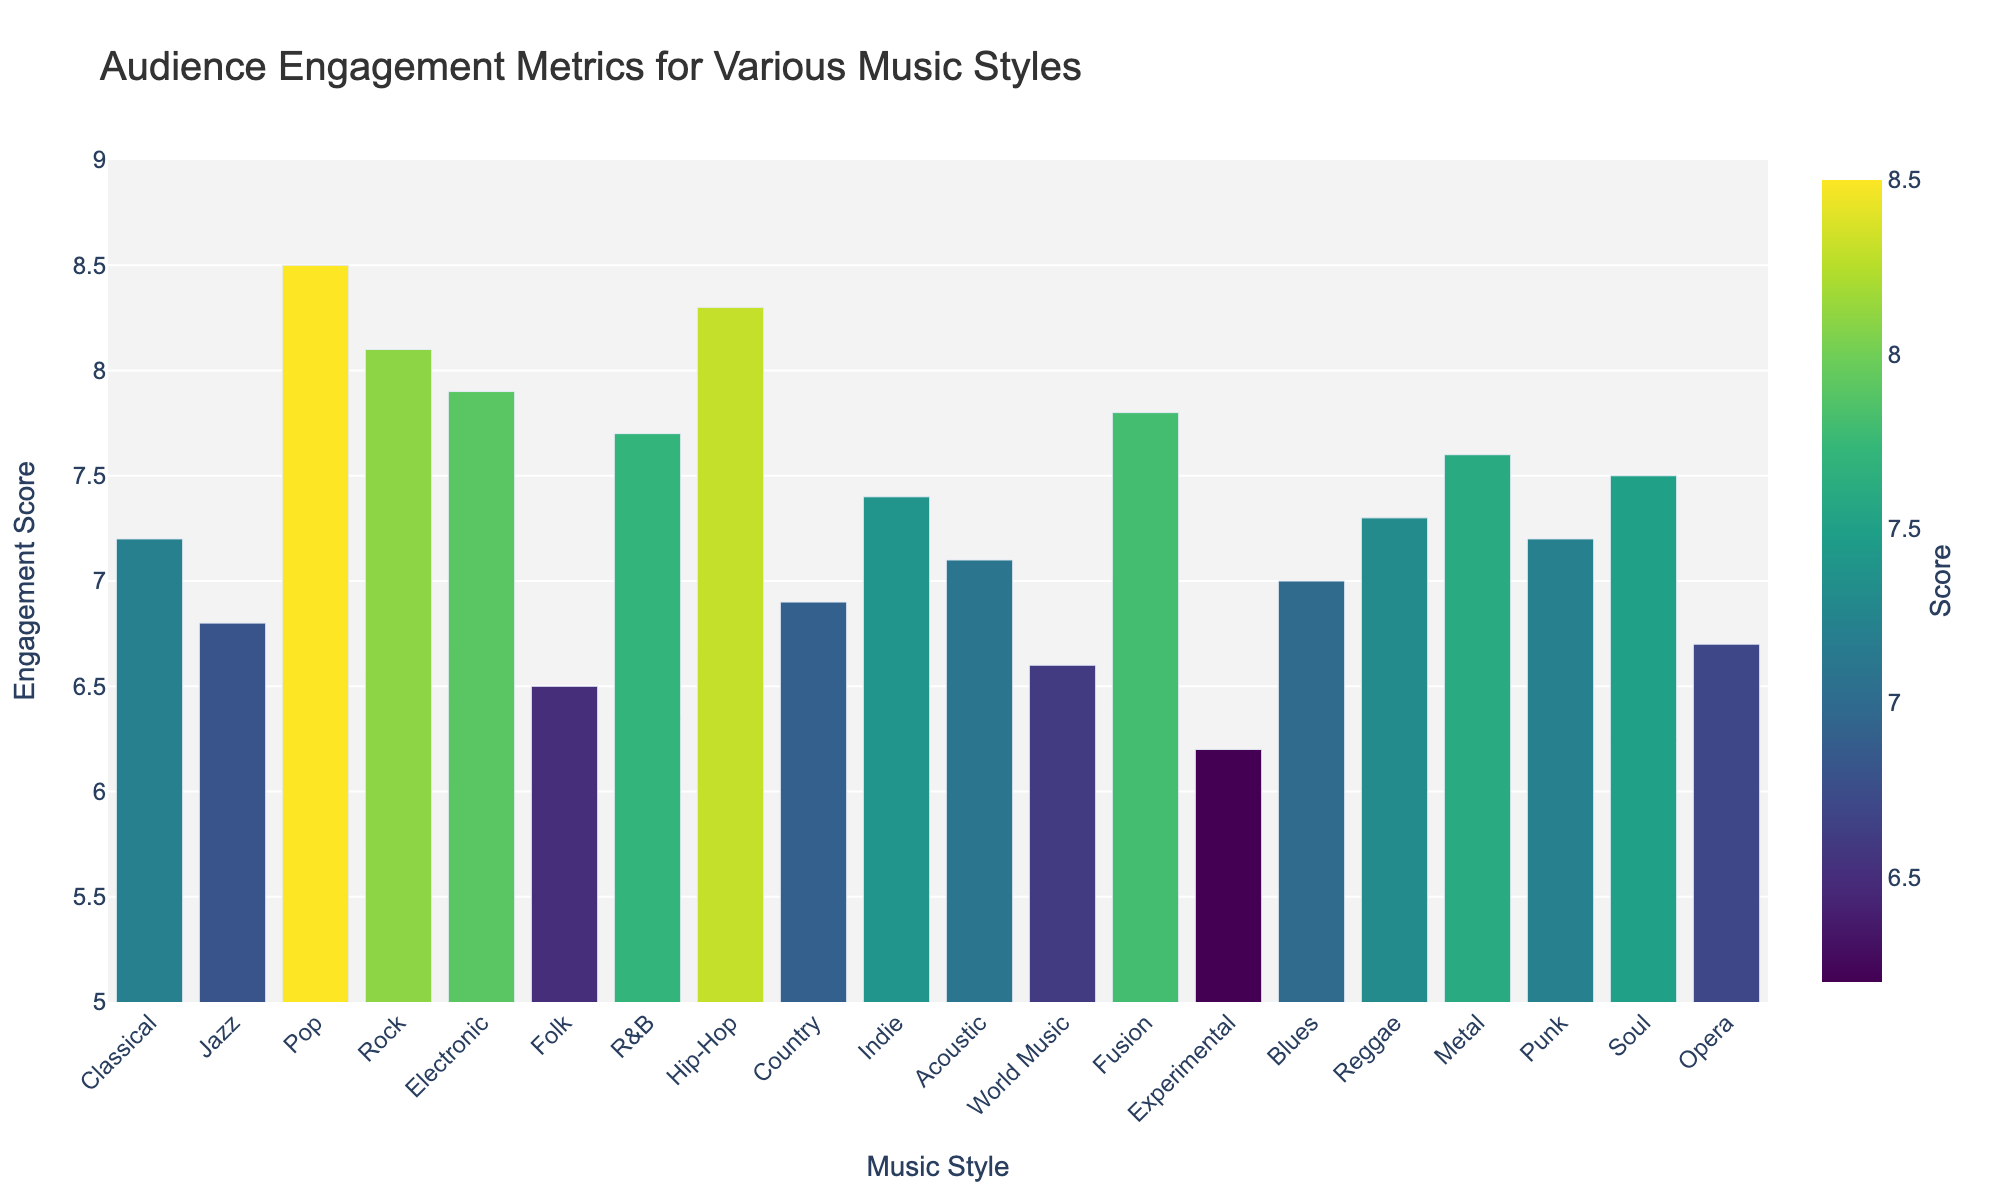Which music style has the highest audience engagement score? The bar representing Pop music has the greatest height, indicating the highest engagement score.
Answer: Pop Which music style has the lowest audience engagement score? The bar representing Experimental music is the shortest, indicating the lowest engagement score.
Answer: Experimental How much higher is the audience engagement score for Rock compared to Classical? The engagement score for Rock is 8.1 and for Classical is 7.2. Subtracting the latter from the former gives 8.1 - 7.2 = 0.9.
Answer: 0.9 Which styles have engagement scores greater than 8? Styles with bars extending beyond the 8 mark on the y-axis include Pop, Rock, and Hip-Hop.
Answer: Pop, Rock, Hip-Hop What is the average engagement score for Classical, Jazz, and Blues? The engagement scores are 7.2 (Classical), 6.8 (Jazz), and 7.0 (Blues). Summing these gives 7.2 + 6.8 + 7.0 = 21.0. Dividing by the number of styles (3) results in 21.0 / 3 = 7.0.
Answer: 7.0 Which genre has a lighter color bar: Reggae or Indie? On the color scale, Reggae has a score of 7.3 and Indie has a score of 7.4. Since higher scores are represented by lighter colors in the Viridis scale, Indie has the lighter color.
Answer: Indie Between R&B and Soul, which has a higher audience engagement score and by how much? The score for R&B is 7.7, and for Soul, it’s 7.5. Subtract 7.5 from 7.7 results in 7.7 - 7.5 = 0.2.
Answer: R&B, by 0.2 Which music styles have engagement scores below 7? Styles with bars not reaching the 7 mark on the y-axis include Jazz, Folk, World Music, Experimental, Opera.
Answer: Jazz, Folk, World Music, Experimental, Opera Is the average engagement score of Pop, R&B, and Metal greater than 8? The scores are 8.5 (Pop), 7.7 (R&B), and 7.6 (Metal). The sum of these scores is 8.5 + 7.7 + 7.6 = 23.8. Divided by 3 results in 23.8 / 3 = 7.93, which is less than 8.
Answer: No How many music styles have an engagement score between 6.5 and 7.5 inclusive? Styles with scores in this range are Classical, Jazz, Folk, Country, Indie, Acoustic, World Music, Blues, Reggae, Opera, Soul (20 + 6). Counting these gives us total of 11.
Answer: 11 